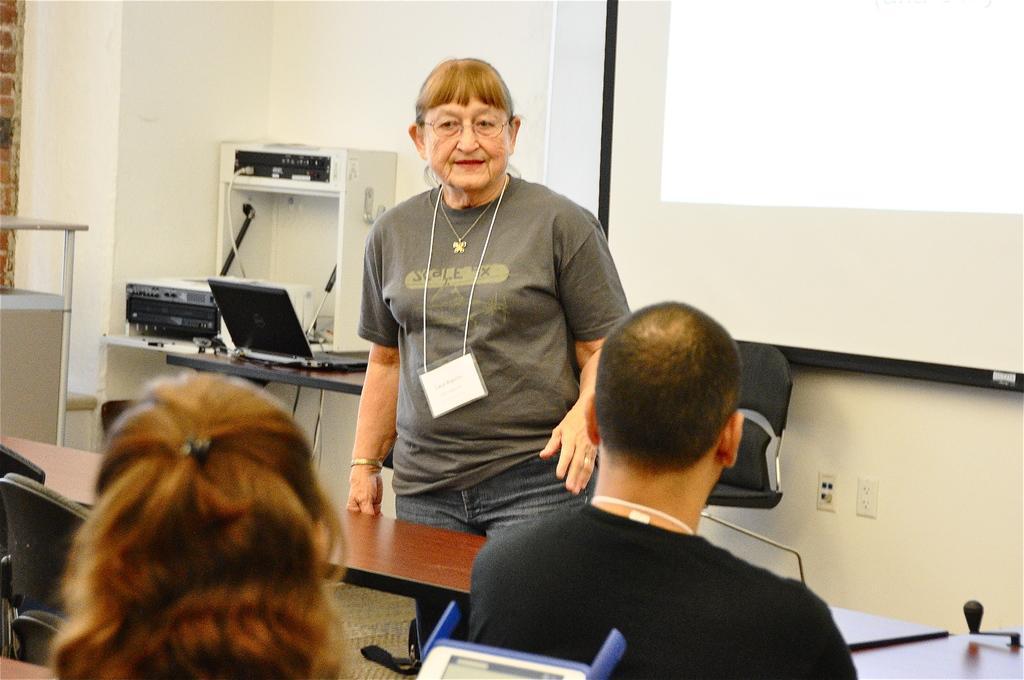In one or two sentences, can you explain what this image depicts? The picture is taken in a room. In the foreground of the picture there are chairs, benches and people. On the left there is a desk, on the desk there are laptop, printer and other objects. On the right there is a projector screen. In the center there is a chair. The wall is painted white. 